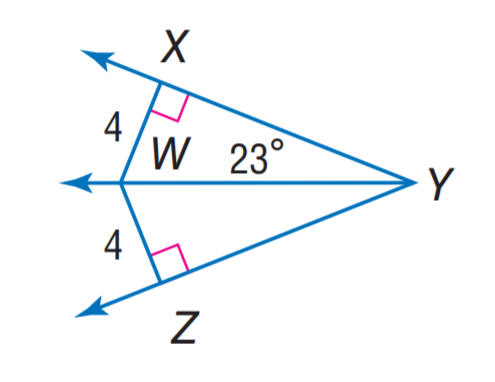Answer the mathemtical geometry problem and directly provide the correct option letter.
Question: Find z.
Choices: A: 2 \sqrt { 6 } B: \sqrt { 33 } C: 2 \sqrt { 11 } D: 24 A 